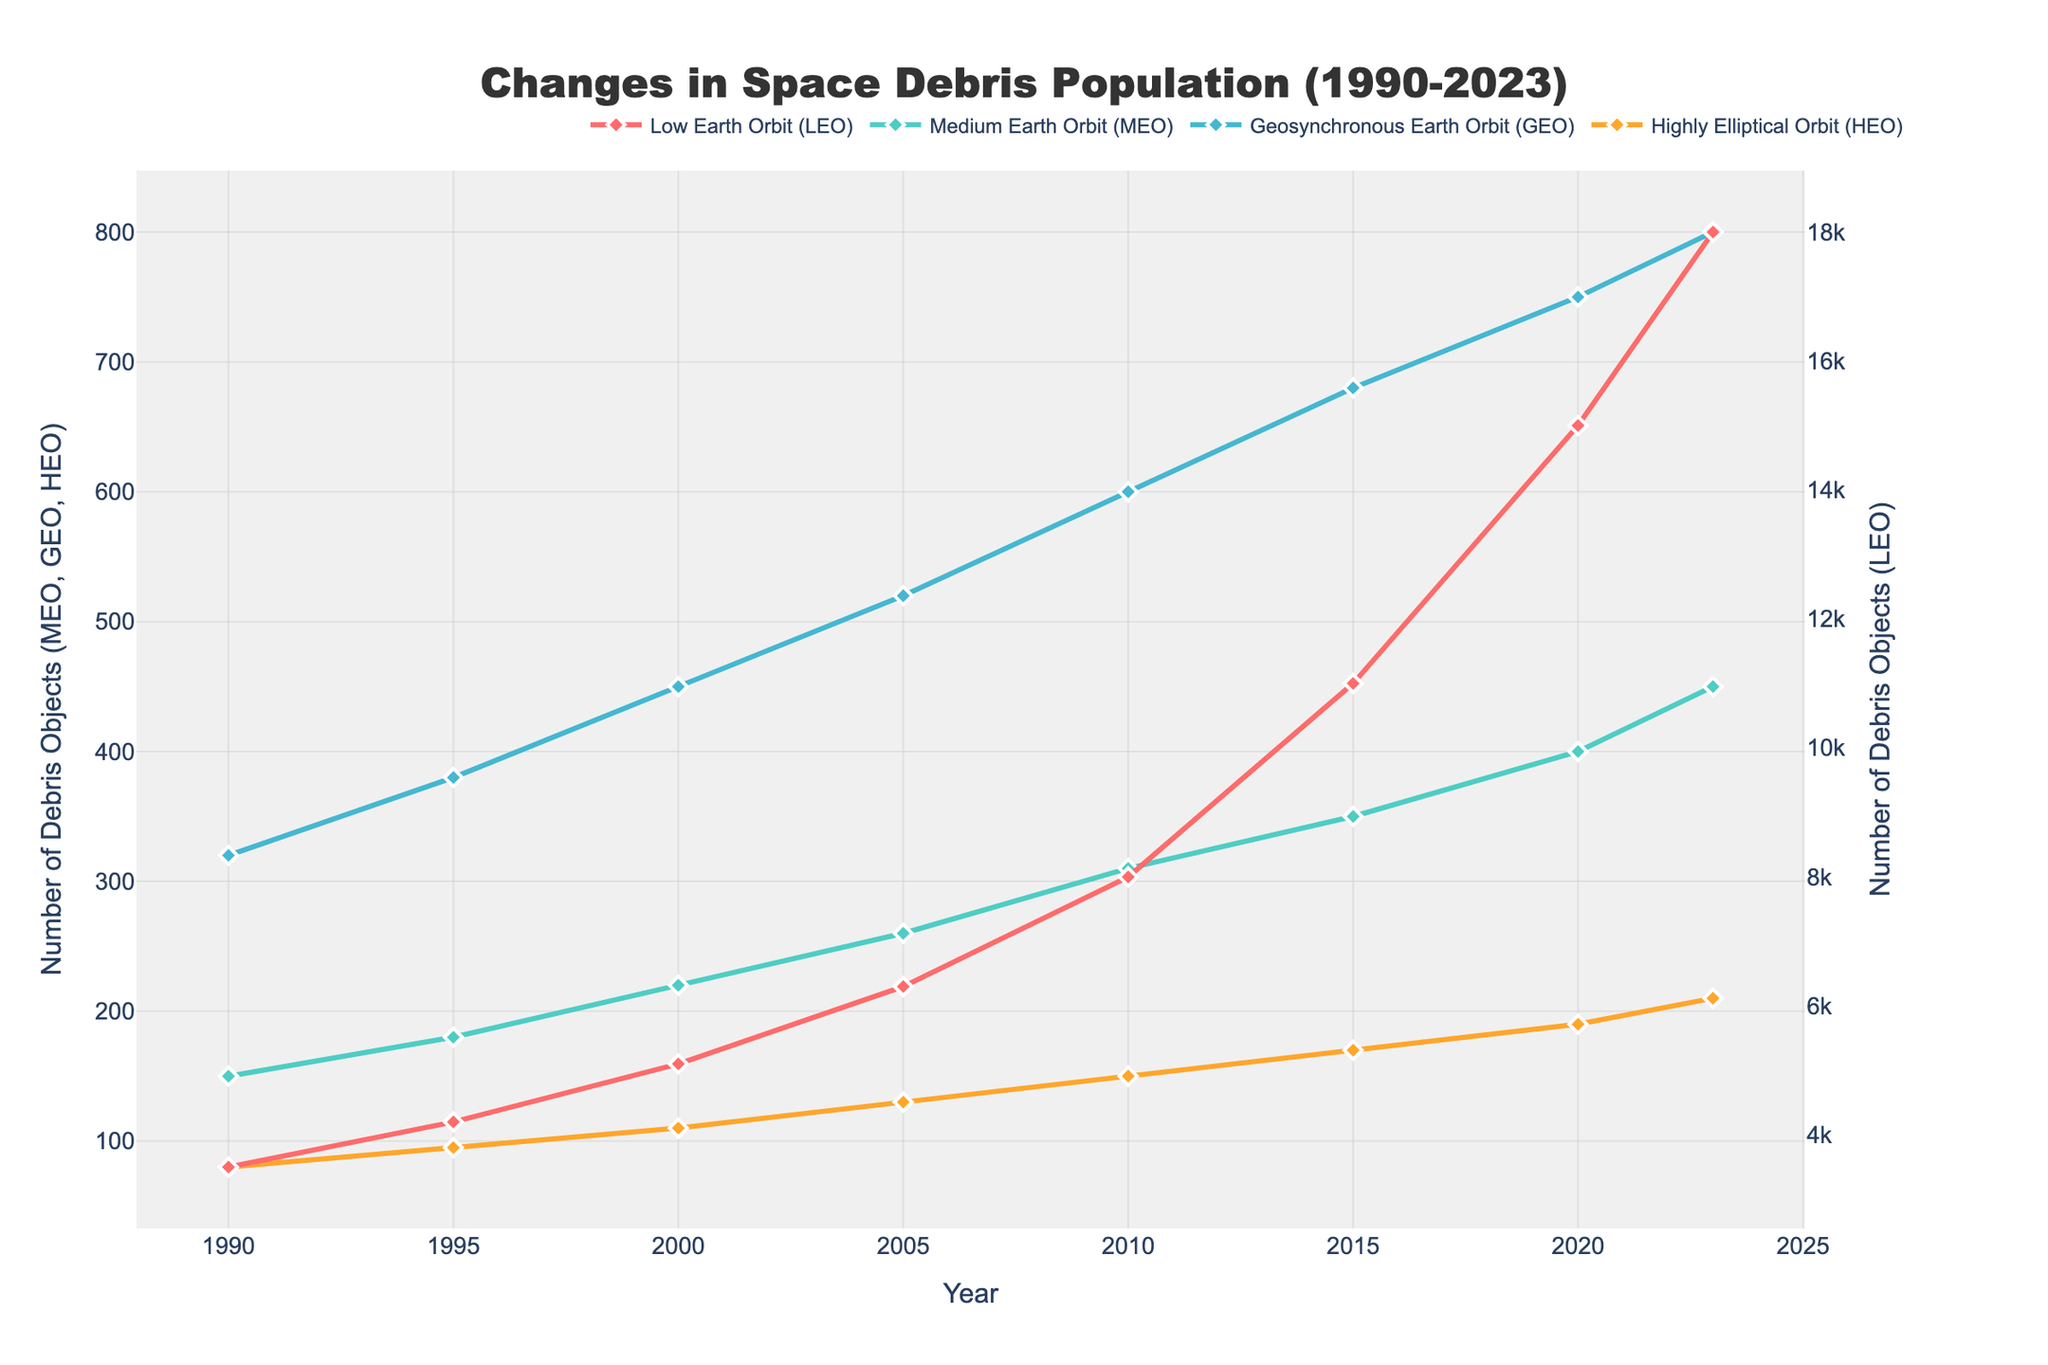Which Earth orbit shows the highest increase in space debris population from 1990 to 2023? To determine which orbit shows the highest increase, look at the starting and ending values for each orbit. LEO went from 3500 to 18000, which is an increase of 14500; MEO went from 150 to 450, an increase of 300; GEO went from 320 to 800, an increase of 480; HEO went from 80 to 210, an increase of 130.
Answer: Low Earth Orbit (LEO) What is the total debris population across all orbits in the year 2023? To find the total, sum the debris populations of all orbits in 2023: LEO (18000) + MEO (450) + GEO (800) + HEO (210) = 19460.
Answer: 19460 By how much did the space debris population in Medium Earth Orbit (MEO) increase from 2000 to 2020? Subtract the MEO value in 2000 from the MEO value in 2020: 400 - 220 = 180.
Answer: 180 Which year shows a larger population of debris in Geosynchronous Earth Orbit (GEO) than in Highly Elliptical Orbit (HEO)? Compare GEO and HEO values for each year. For 1990: 320 > 80; 1995: 380 > 95; 2000: 450 > 110; 2005: 520 > 130; 2010: 600 > 150; 2015: 680 > 170; 2020: 750 > 190; 2023: 800 > 210. Each year from 1990 to 2023 meets the criterion.
Answer: Every year from 1990 to 2023 What is the average annual increase in the space debris population in Low Earth Orbit (LEO) between 2010 and 2023? Calculate the increase from 2010 to 2023 for LEO, then divide by the number of years. Increase: 18000 - 8000 = 10000. Number of years: 2023 - 2010 = 13. Average annual increase: 10000 / 13 ≈ 769.
Answer: Approximately 769 Is the increase in the debris population for Geosynchronous Earth Orbit (GEO) greater than for Medium Earth Orbit (MEO) from 1990 to 2023? Calculate the increase for GEO: 800 - 320 = 480. Calculate the increase for MEO: 450 - 150 = 300. Compare the two increases: 480 > 300.
Answer: Yes By which factor did the debris population in Low Earth Orbit (LEO) grow from 2000 to 2023? Divide the LEO population in 2023 by the LEO population in 2000: 18000 / 5100 ≈ 3.53.
Answer: 3.53 Between which years did Highly Elliptical Orbit (HEO) see the highest increase in space debris population? Analyze the change in HEO population for every 5-year segment: 1990 to 1995: 95 - 80 = 15; 1995 to 2000: 110 - 95 = 15; 2000 to 2005: 130 - 110 = 20; 2005 to 2010: 150 - 130 = 20; 2010 to 2015: 170 - 150 = 20; 2015 to 2020: 190 - 170 = 20; 2020 to 2023: 210 - 190 = 20. The highest increases (20 objects) are in 2000 to 2005, 2005 to 2010, 2010 to 2015, 2015 to 2020, and 2020 to 2023.
Answer: 2000 to 2023 